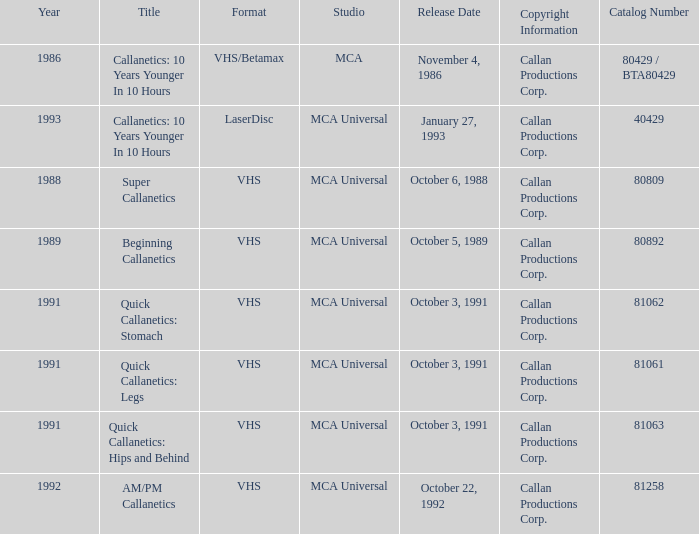Name the format for super callanetics VHS. 